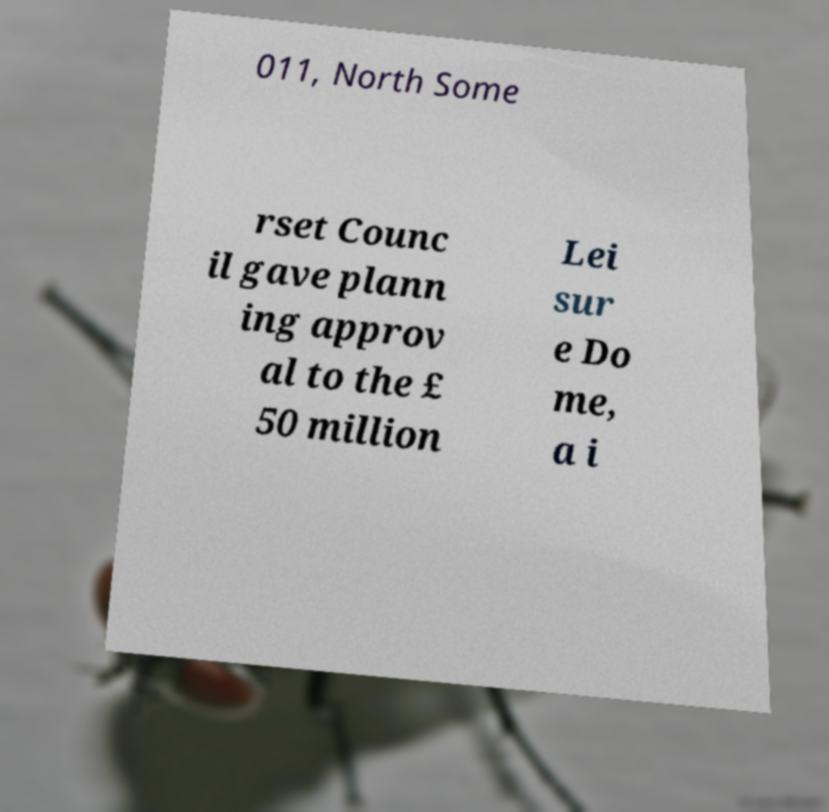Can you accurately transcribe the text from the provided image for me? 011, North Some rset Counc il gave plann ing approv al to the £ 50 million Lei sur e Do me, a i 